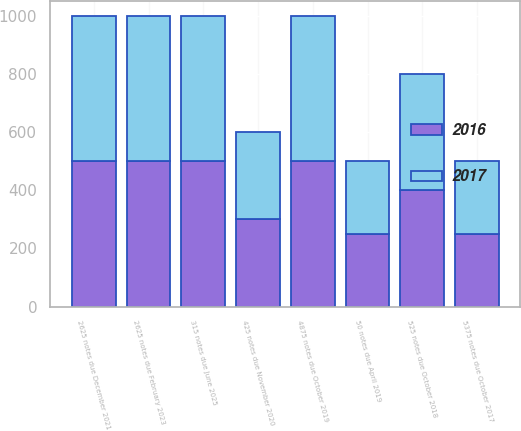<chart> <loc_0><loc_0><loc_500><loc_500><stacked_bar_chart><ecel><fcel>5375 notes due October 2017<fcel>525 notes due October 2018<fcel>50 notes due April 2019<fcel>4875 notes due October 2019<fcel>425 notes due November 2020<fcel>2625 notes due December 2021<fcel>2625 notes due February 2023<fcel>315 notes due June 2025<nl><fcel>2016<fcel>250<fcel>400<fcel>250<fcel>500<fcel>300<fcel>500<fcel>500<fcel>500<nl><fcel>2017<fcel>250<fcel>400<fcel>250<fcel>500<fcel>300<fcel>500<fcel>500<fcel>500<nl></chart> 